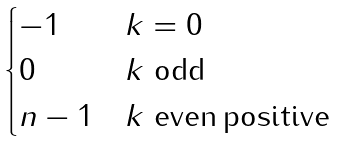Convert formula to latex. <formula><loc_0><loc_0><loc_500><loc_500>\begin{cases} - 1 & \text {$k=0$} \\ 0 & \text {$k$ odd} \\ n - 1 & \text {$k$ even\,positive} \\ \end{cases}</formula> 